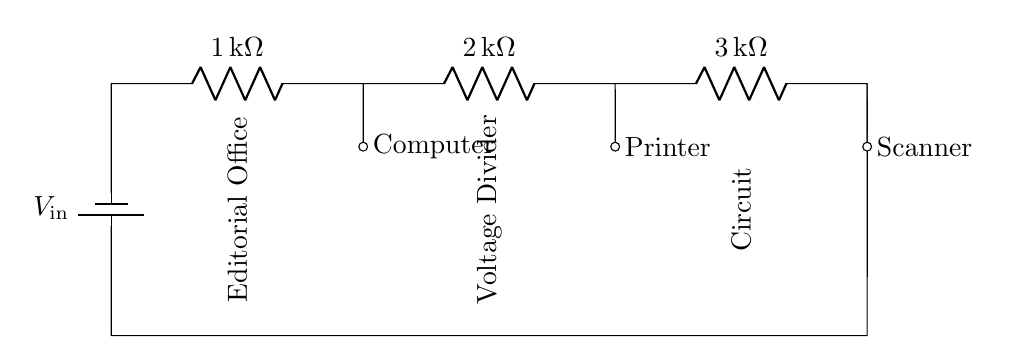What is the input voltage of the circuit? The circuit's power source is a battery labeled with the input voltage, represented as V_in in the diagram.
Answer: V_in What are the resistance values associated with the resistors? The circuit features three resistors, each labeled with their respective resistance values: one with one kilo-ohm, another with two kilo-ohms, and the last with three kilo-ohms.
Answer: 1 kilo-ohm, 2 kilo-ohm, 3 kilo-ohm What type of circuit configuration is shown? The circuit configuration is a series circuit, indicated by the sequential arrangement of resistors connected end-to-end between the battery and ground.
Answer: Series circuit How many electronic devices are powered by this circuit? The circuit diagram shows three electronic devices connected to the resistors, illustrating that the voltage at different points distributes across these devices.
Answer: Three devices What is the purpose of the voltage divider in this context? The voltage divider is used to reduce the input voltage from the battery to appropriate levels that can safely operate the connected devices in the editorial office.
Answer: Reduce voltage Which electronic device may require the least voltage? Given the resistors and their arrangement, the first device connected to the lowest resistance would likely require less voltage than the others, typically the device connected to the first resistor.
Answer: Computer What does the diagram indicate about the connections? The connections are shown as direct lines that indicate the flow of current through the various components, with devices receiving voltage as they are connected to different points across the resistors.
Answer: Direct connections 